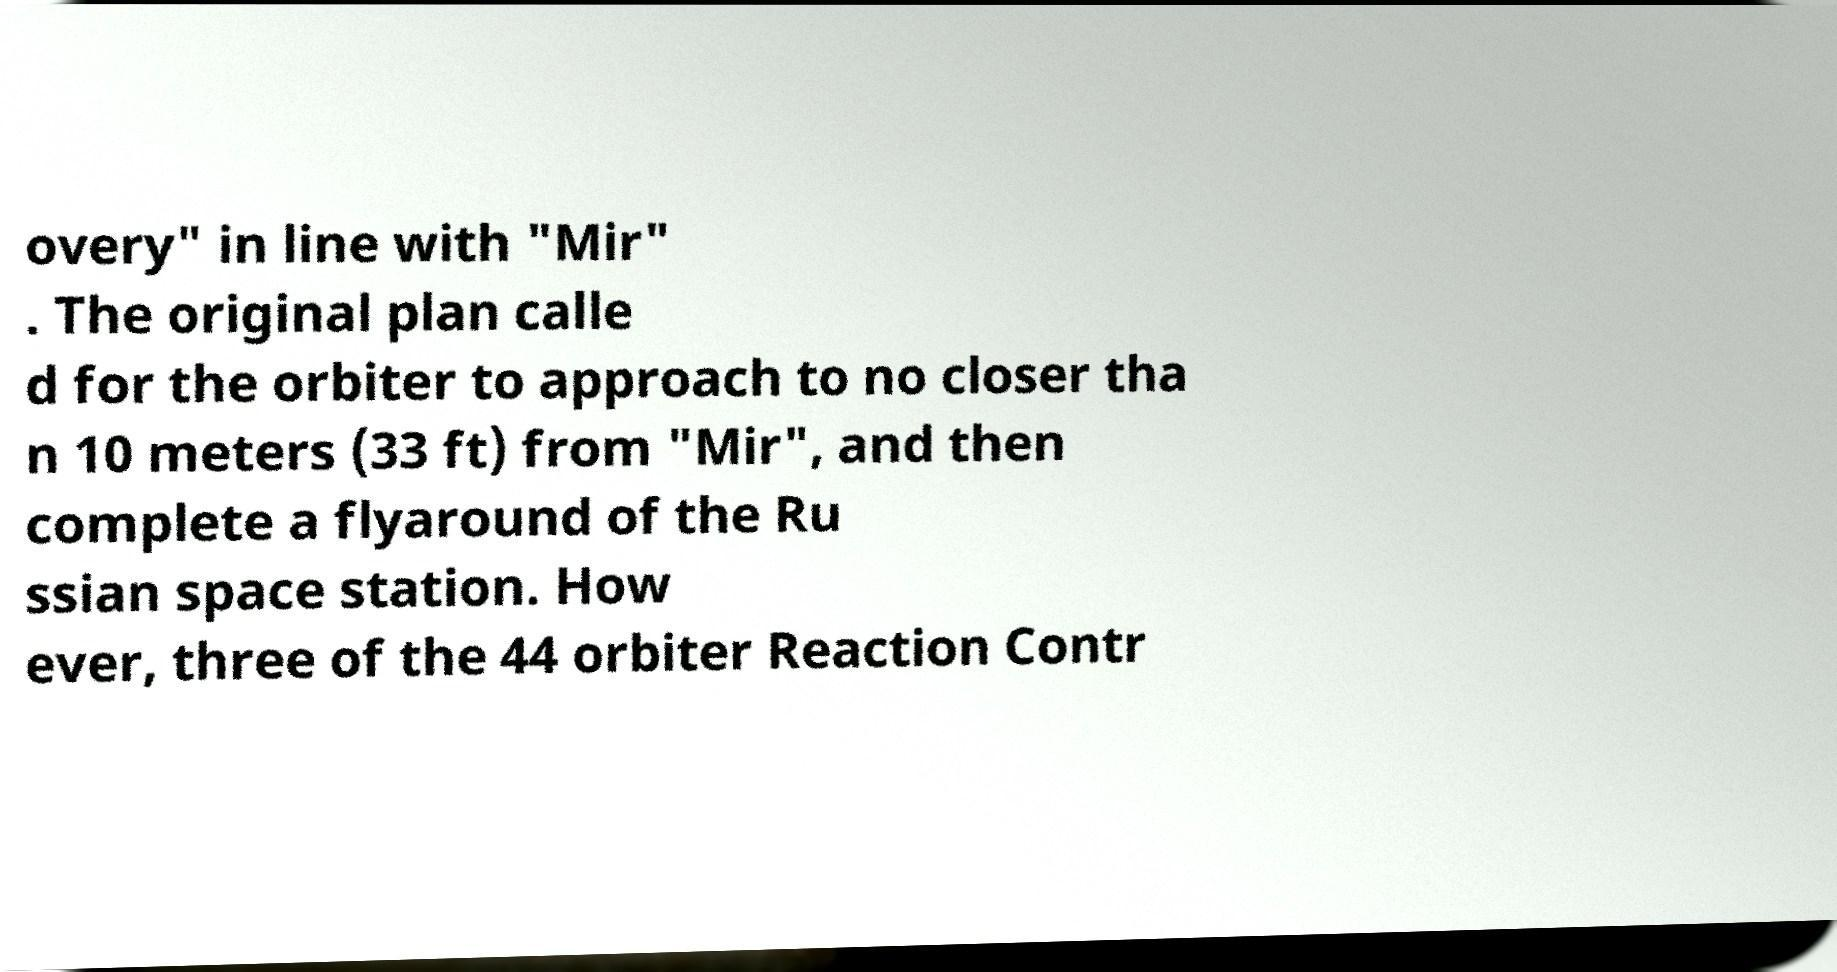I need the written content from this picture converted into text. Can you do that? overy" in line with "Mir" . The original plan calle d for the orbiter to approach to no closer tha n 10 meters (33 ft) from "Mir", and then complete a flyaround of the Ru ssian space station. How ever, three of the 44 orbiter Reaction Contr 